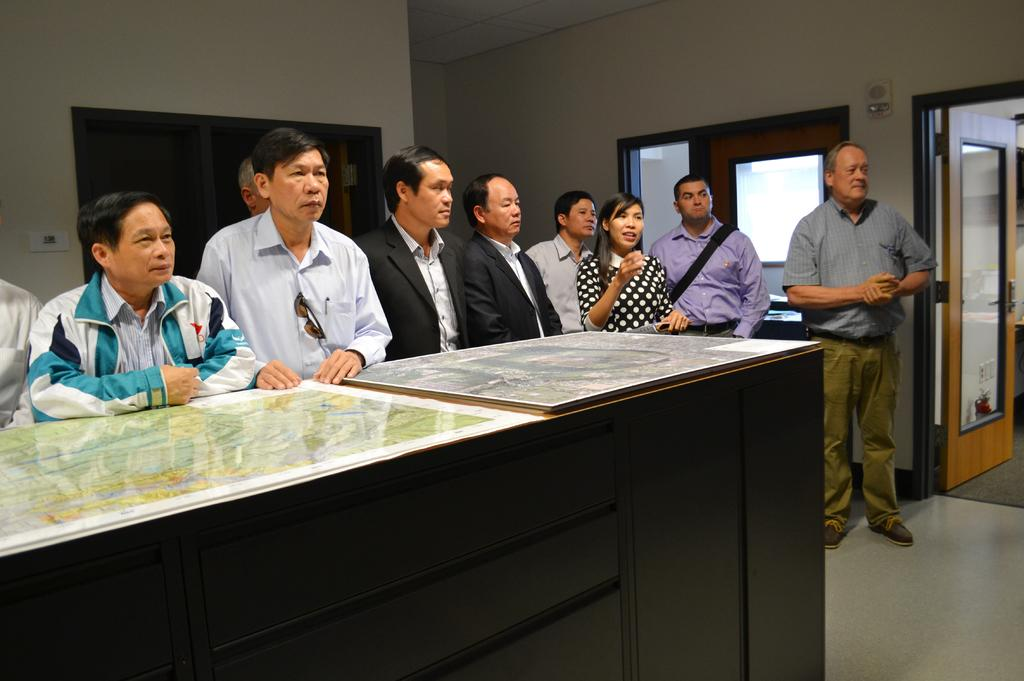How many people are in the room in the image? There is a group of people in the room in the image. What are the people doing in the image? The people are standing near a wooden table and looking at someone. What can be seen in the background of the image? There are windows and doors in the background. What type of scarf is the person wearing in the image? There is no person wearing a scarf in the image; the people are looking at someone, but no one is wearing a scarf. 